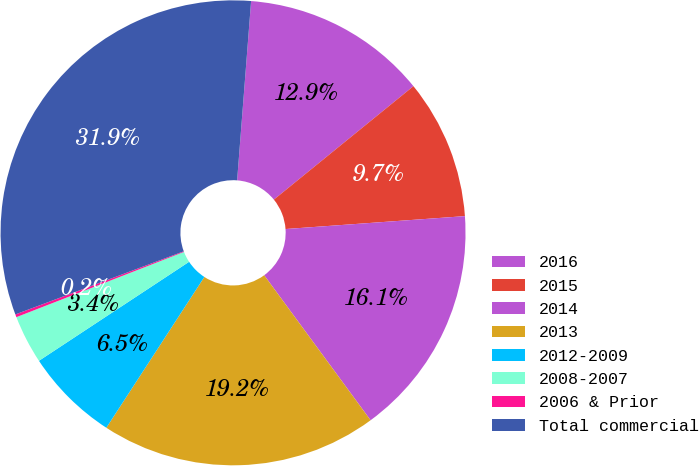<chart> <loc_0><loc_0><loc_500><loc_500><pie_chart><fcel>2016<fcel>2015<fcel>2014<fcel>2013<fcel>2012-2009<fcel>2008-2007<fcel>2006 & Prior<fcel>Total commercial<nl><fcel>12.9%<fcel>9.72%<fcel>16.07%<fcel>19.25%<fcel>6.55%<fcel>3.37%<fcel>0.2%<fcel>31.95%<nl></chart> 